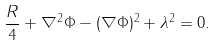<formula> <loc_0><loc_0><loc_500><loc_500>\frac { R } { 4 } + \nabla ^ { 2 } \Phi - ( \nabla \Phi ) ^ { 2 } + \lambda ^ { 2 } = 0 .</formula> 